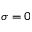Convert formula to latex. <formula><loc_0><loc_0><loc_500><loc_500>\sigma = 0</formula> 